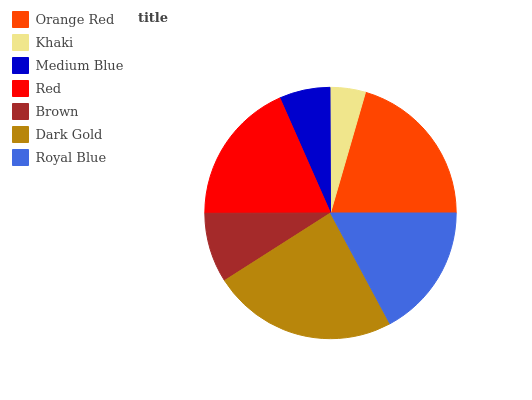Is Khaki the minimum?
Answer yes or no. Yes. Is Dark Gold the maximum?
Answer yes or no. Yes. Is Medium Blue the minimum?
Answer yes or no. No. Is Medium Blue the maximum?
Answer yes or no. No. Is Medium Blue greater than Khaki?
Answer yes or no. Yes. Is Khaki less than Medium Blue?
Answer yes or no. Yes. Is Khaki greater than Medium Blue?
Answer yes or no. No. Is Medium Blue less than Khaki?
Answer yes or no. No. Is Royal Blue the high median?
Answer yes or no. Yes. Is Royal Blue the low median?
Answer yes or no. Yes. Is Dark Gold the high median?
Answer yes or no. No. Is Khaki the low median?
Answer yes or no. No. 